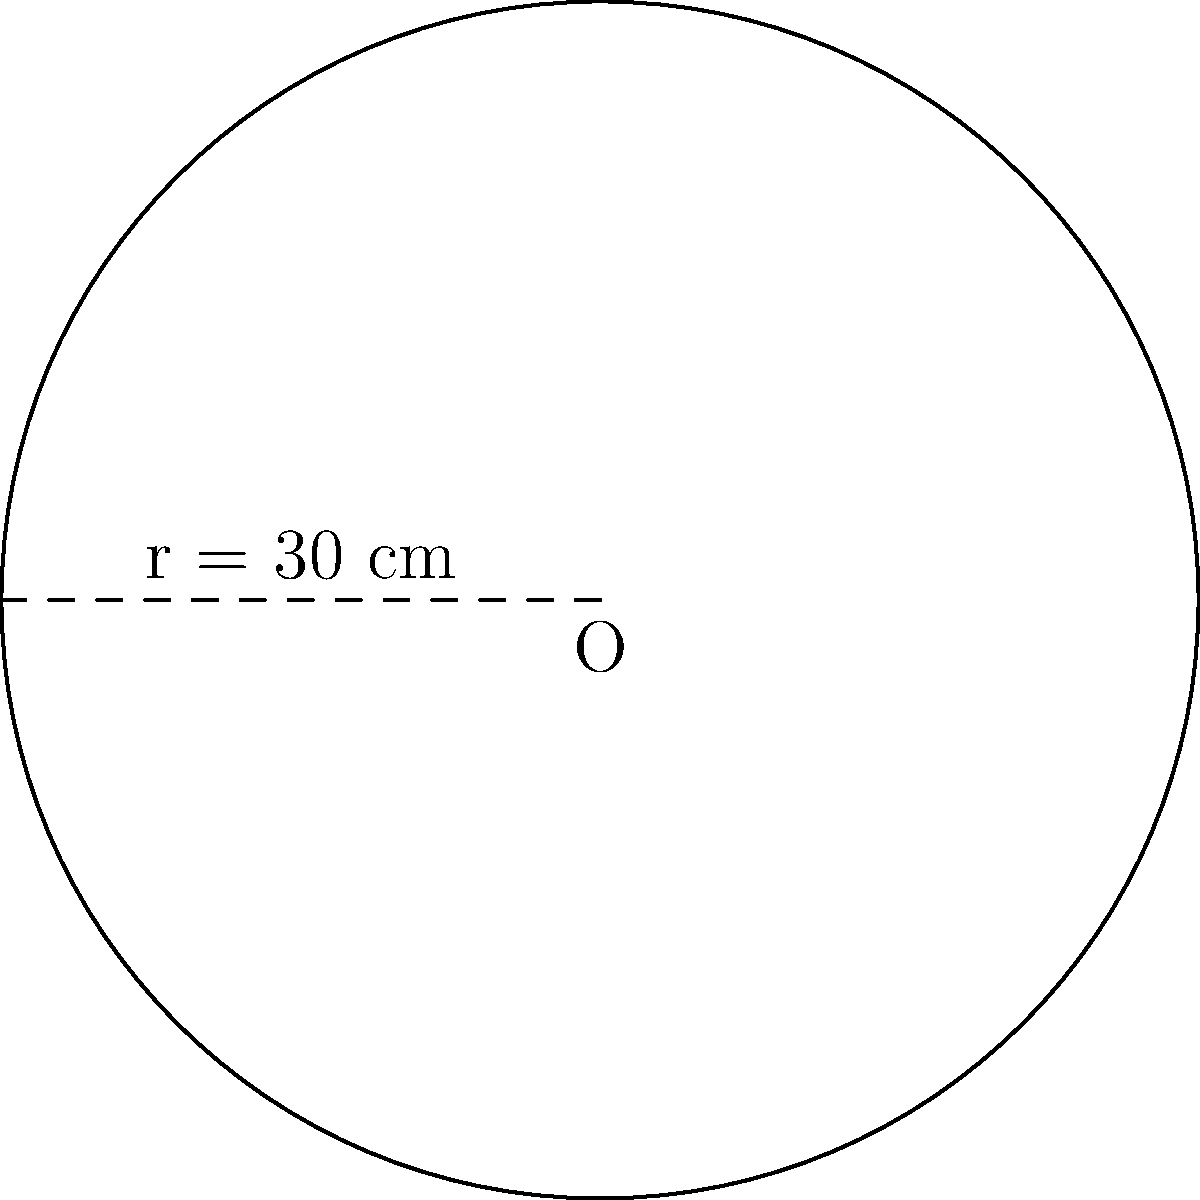As part of your digital humanities project, you're designing a circular display case for a rare medieval manuscript. If the radius of the case is 30 cm, what is the area of the circular base needed to house the artifact? Round your answer to the nearest square centimeter. To calculate the area of a circular display case, we need to use the formula for the area of a circle:

$$A = \pi r^2$$

Where:
$A$ = area of the circle
$\pi$ = pi (approximately 3.14159)
$r$ = radius of the circle

Given:
Radius ($r$) = 30 cm

Step 1: Substitute the given radius into the formula.
$$A = \pi (30\text{ cm})^2$$

Step 2: Calculate the square of the radius.
$$A = \pi (900\text{ cm}^2)$$

Step 3: Multiply by π.
$$A = 2827.43\text{ cm}^2$$

Step 4: Round to the nearest square centimeter.
$$A \approx 2827\text{ cm}^2$$

Therefore, the area of the circular base needed for the display case is approximately 2827 square centimeters.
Answer: 2827 cm² 